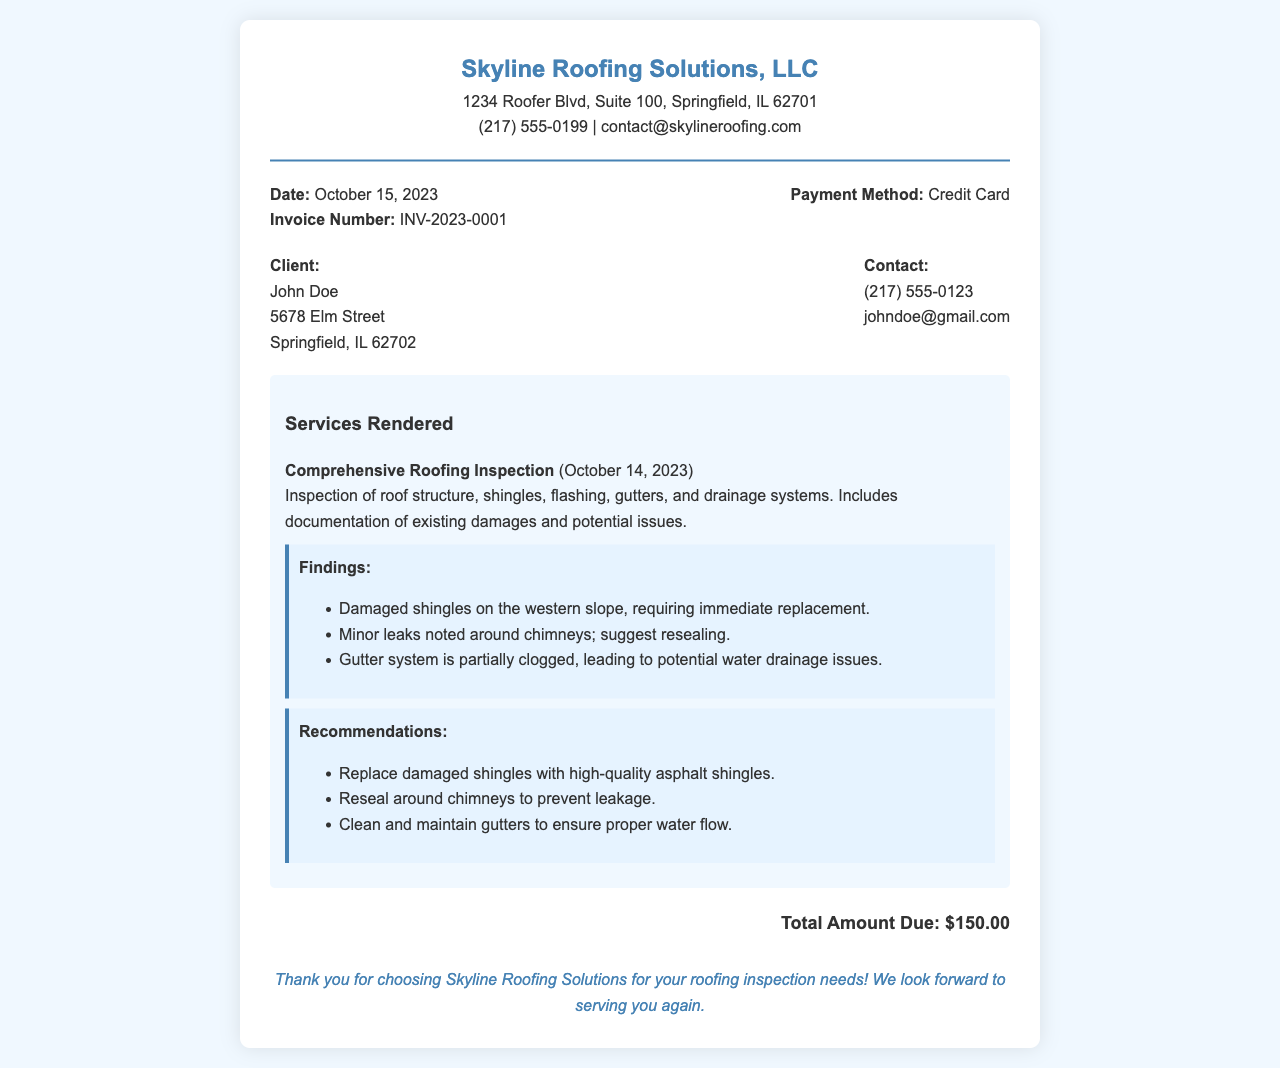What is the company name? The company name is provided in the header of the receipt.
Answer: Skyline Roofing Solutions, LLC What is the client's address? The client’s address is listed in the client details section of the receipt.
Answer: 5678 Elm Street, Springfield, IL 62702 What was the invoice date? The date of the invoice is noted in the receipt details section.
Answer: October 15, 2023 How much is the total amount due? The total amount due is clearly stated in the total section of the receipt.
Answer: $150.00 What were the findings regarding the shingles? The findings regarding the shingles are documented under the findings section.
Answer: Damaged shingles on the western slope, requiring immediate replacement What is recommended for the chimney leaks? The recommendations are outlined in the recommendations section of the document.
Answer: Reseal around chimneys to prevent leakage What payment method was used? The payment method is specified in the receipt details section.
Answer: Credit Card When was the roofing inspection conducted? The date of the inspection is mentioned in the services rendered.
Answer: October 14, 2023 What is the contact email for the company? The contact email for the company is provided in the header of the receipt.
Answer: contact@skylineroofing.com 